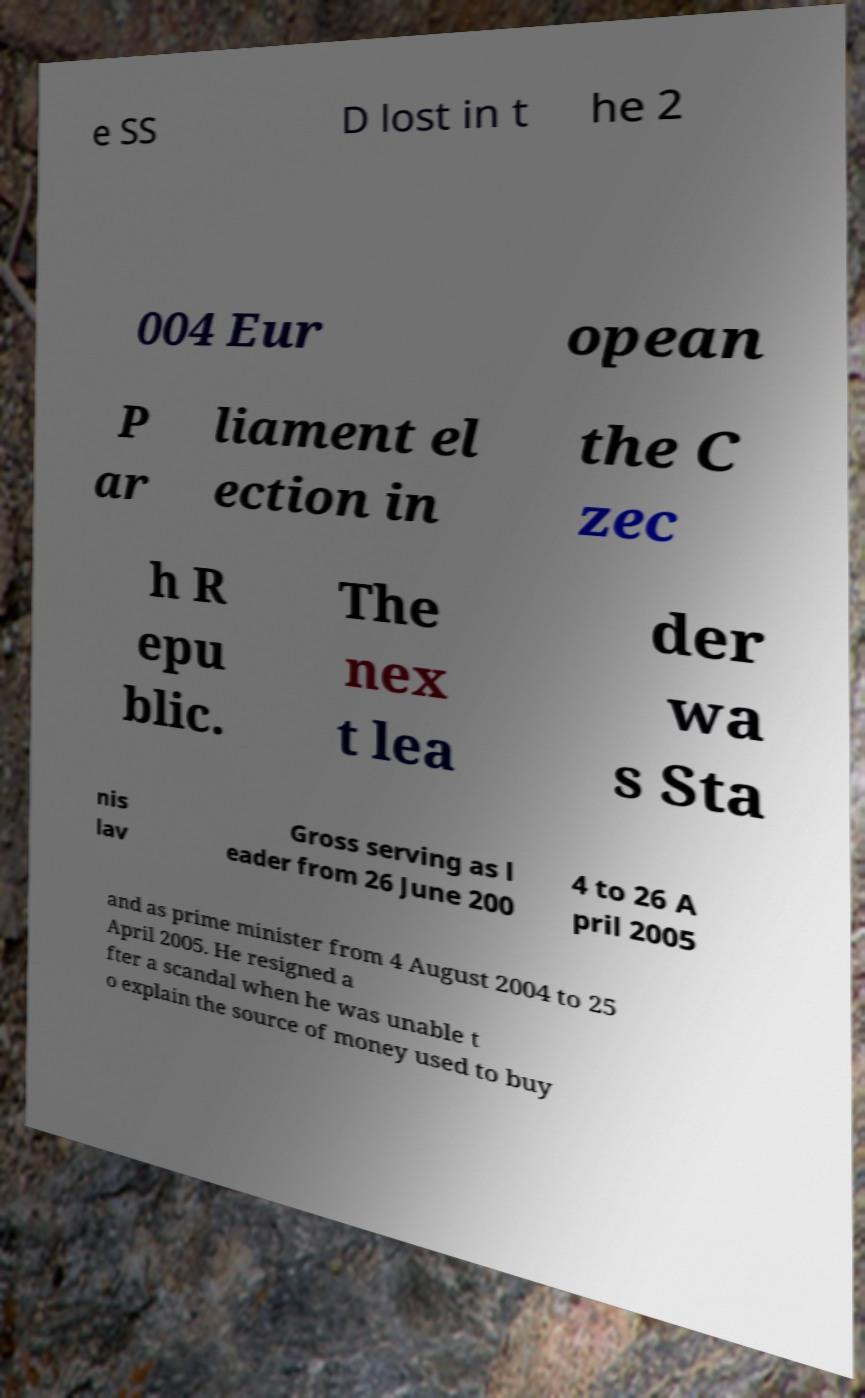There's text embedded in this image that I need extracted. Can you transcribe it verbatim? e SS D lost in t he 2 004 Eur opean P ar liament el ection in the C zec h R epu blic. The nex t lea der wa s Sta nis lav Gross serving as l eader from 26 June 200 4 to 26 A pril 2005 and as prime minister from 4 August 2004 to 25 April 2005. He resigned a fter a scandal when he was unable t o explain the source of money used to buy 